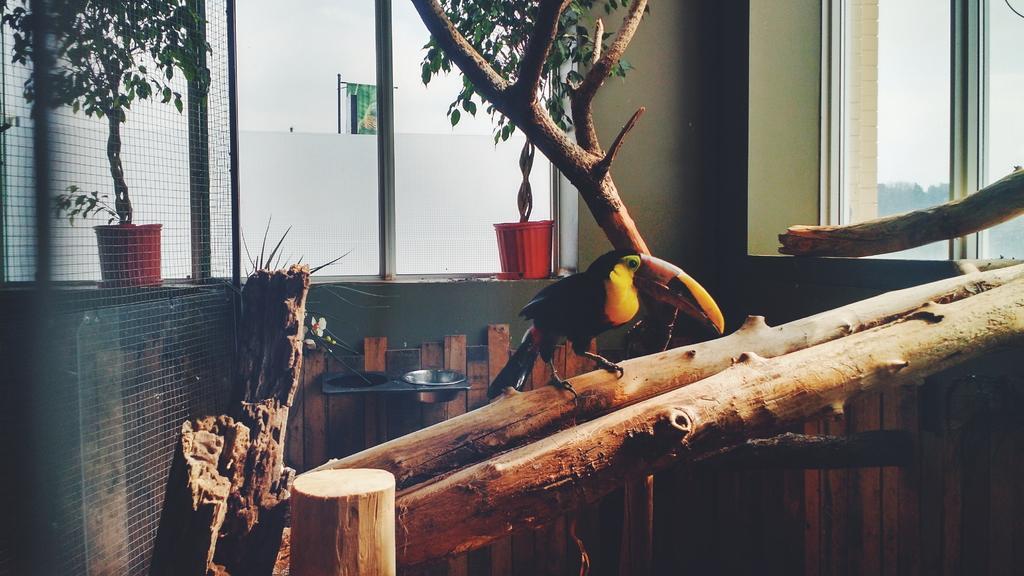In one or two sentences, can you explain what this image depicts? In this image in the center there is a bird standing on the branch of a tree. In the background on the left side there is a fence and behind the fence there is a pot and a plant. In the background there is a plant and there is a pot which is red in colour and there are windows. 